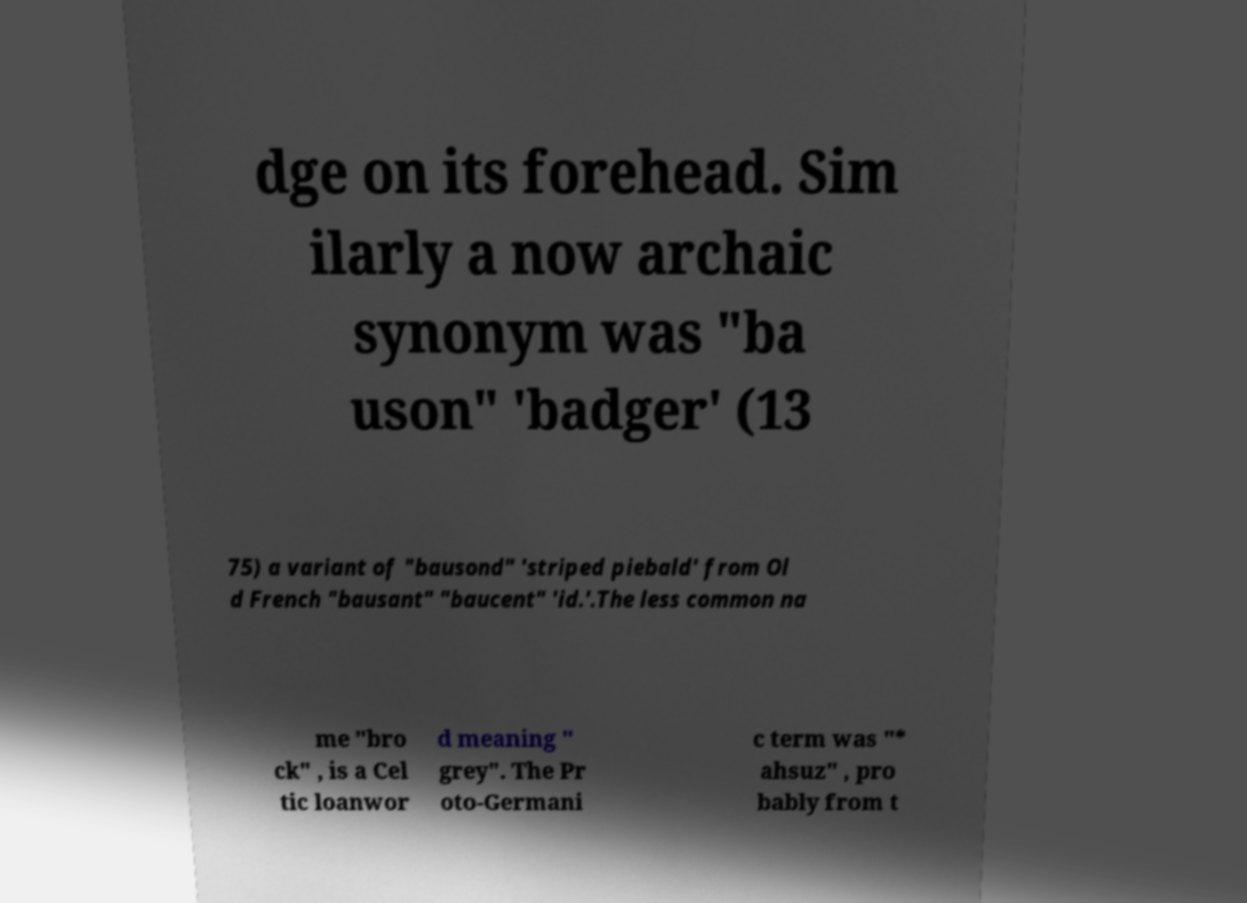Could you assist in decoding the text presented in this image and type it out clearly? dge on its forehead. Sim ilarly a now archaic synonym was "ba uson" 'badger' (13 75) a variant of "bausond" 'striped piebald' from Ol d French "bausant" "baucent" 'id.'.The less common na me "bro ck" , is a Cel tic loanwor d meaning " grey". The Pr oto-Germani c term was "* ahsuz" , pro bably from t 